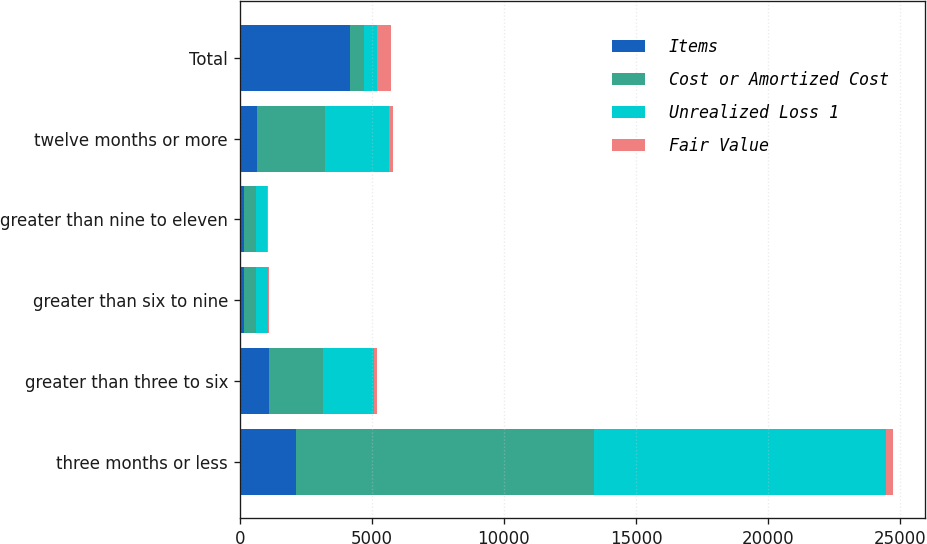Convert chart to OTSL. <chart><loc_0><loc_0><loc_500><loc_500><stacked_bar_chart><ecel><fcel>three months or less<fcel>greater than three to six<fcel>greater than six to nine<fcel>greater than nine to eleven<fcel>twelve months or more<fcel>Total<nl><fcel>Items<fcel>2119<fcel>1109<fcel>151<fcel>151<fcel>657<fcel>4187<nl><fcel>Cost or Amortized Cost<fcel>11299<fcel>2039<fcel>484<fcel>452<fcel>2565<fcel>504.5<nl><fcel>Unrealized Loss 1<fcel>11037<fcel>1934<fcel>456<fcel>441<fcel>2446<fcel>504.5<nl><fcel>Fair Value<fcel>262<fcel>105<fcel>28<fcel>11<fcel>119<fcel>525<nl></chart> 